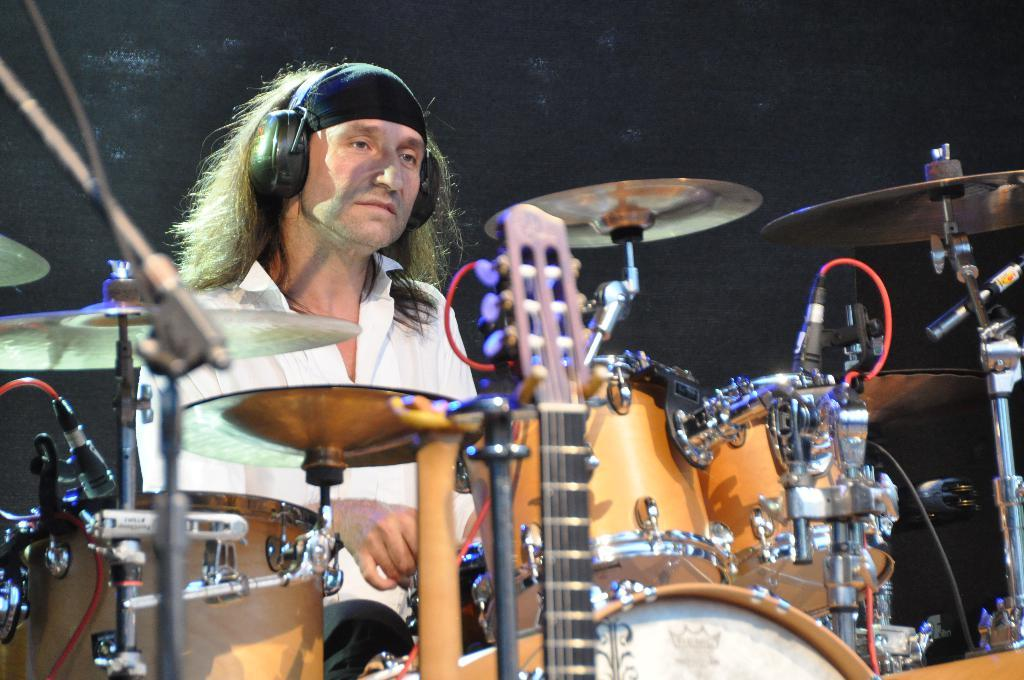What is the person in the image doing? The person is playing drums. What is the person wearing? The person is wearing a white shirt. What other objects are present in the image? There are musical instruments in the image. What is the color of the background in the image? The background of the image is in black color. What type of linen is draped over the square in the image? There is no linen or square present in the image. How many mittens can be seen on the person's hands in the image? The person is not wearing mittens in the image; they are playing drums with their hands. 